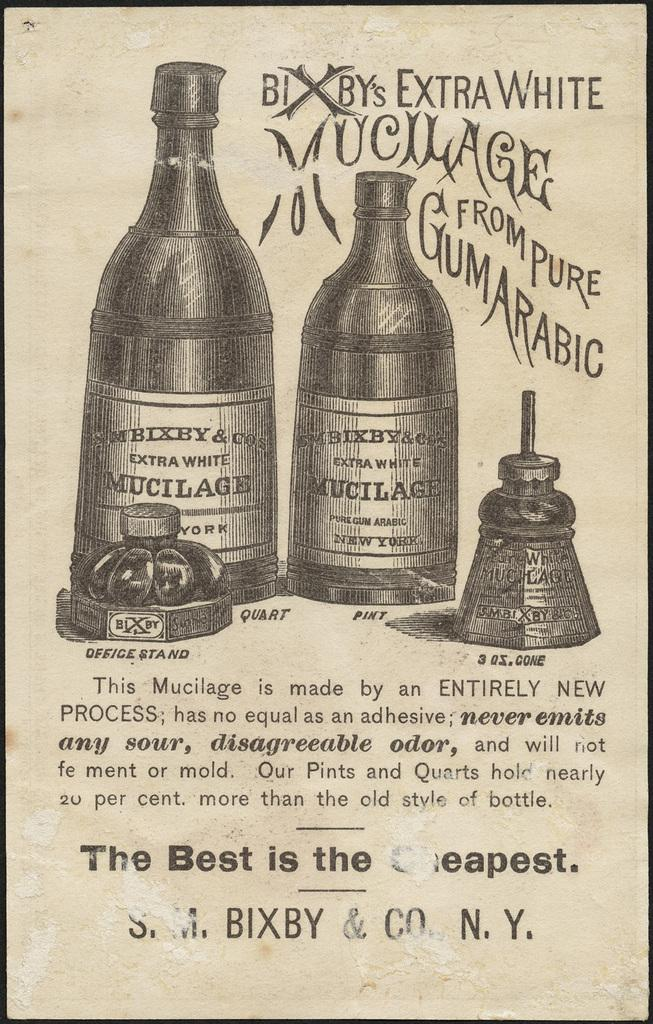Provide a one-sentence caption for the provided image. Drawing of beer for Bixby's Extra White from Pure Gum Arabic. 